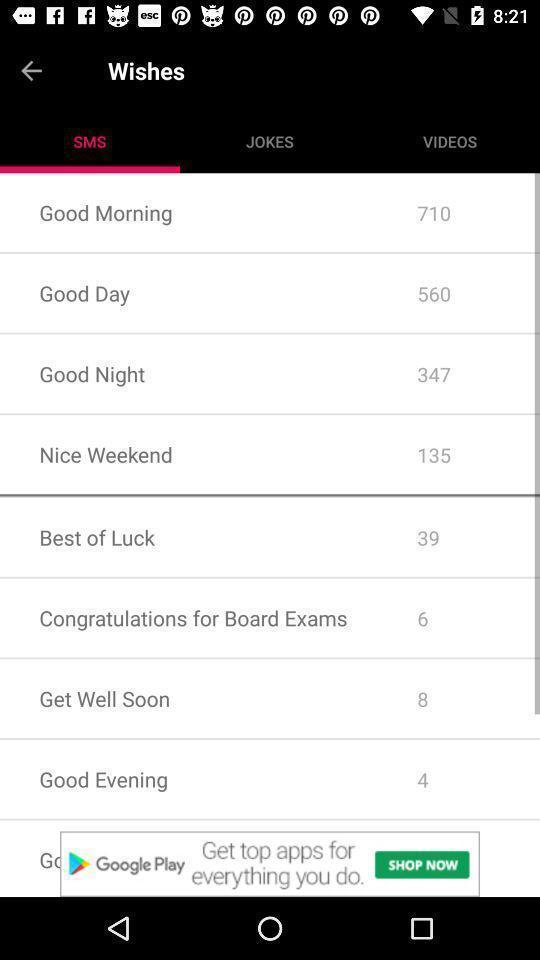Describe the key features of this screenshot. Screen showing list of various wishes in social app. 